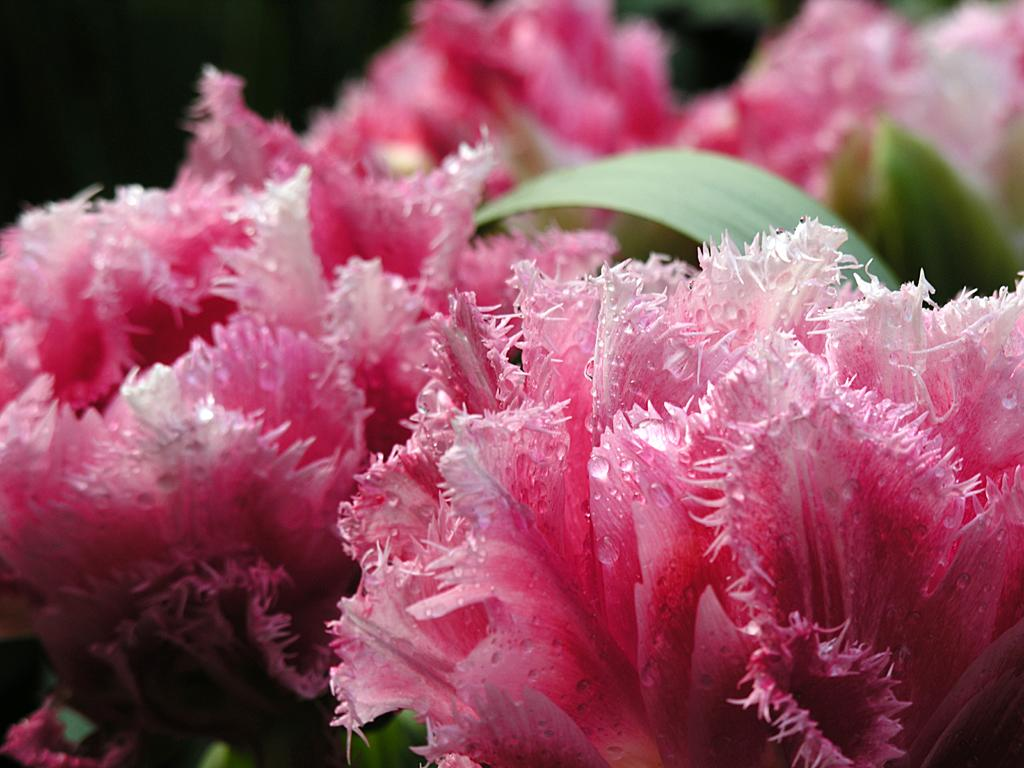What type of flowers are present in the image? There are pink color flowers in the image. What other parts of the flowers can be seen besides the petals? The flowers have leaves. How would you describe the overall appearance of the image? The background of the image is dark. What type of father can be seen in the image? There is no father present in the image; it only features pink color flowers with leaves against a dark background. 